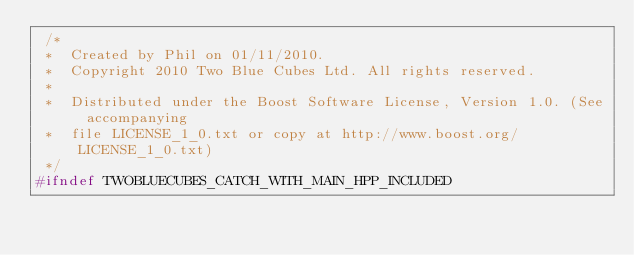Convert code to text. <code><loc_0><loc_0><loc_500><loc_500><_C++_> /*
 *  Created by Phil on 01/11/2010.
 *  Copyright 2010 Two Blue Cubes Ltd. All rights reserved.
 *
 *  Distributed under the Boost Software License, Version 1.0. (See accompanying
 *  file LICENSE_1_0.txt or copy at http://www.boost.org/LICENSE_1_0.txt)
 */
#ifndef TWOBLUECUBES_CATCH_WITH_MAIN_HPP_INCLUDED</code> 